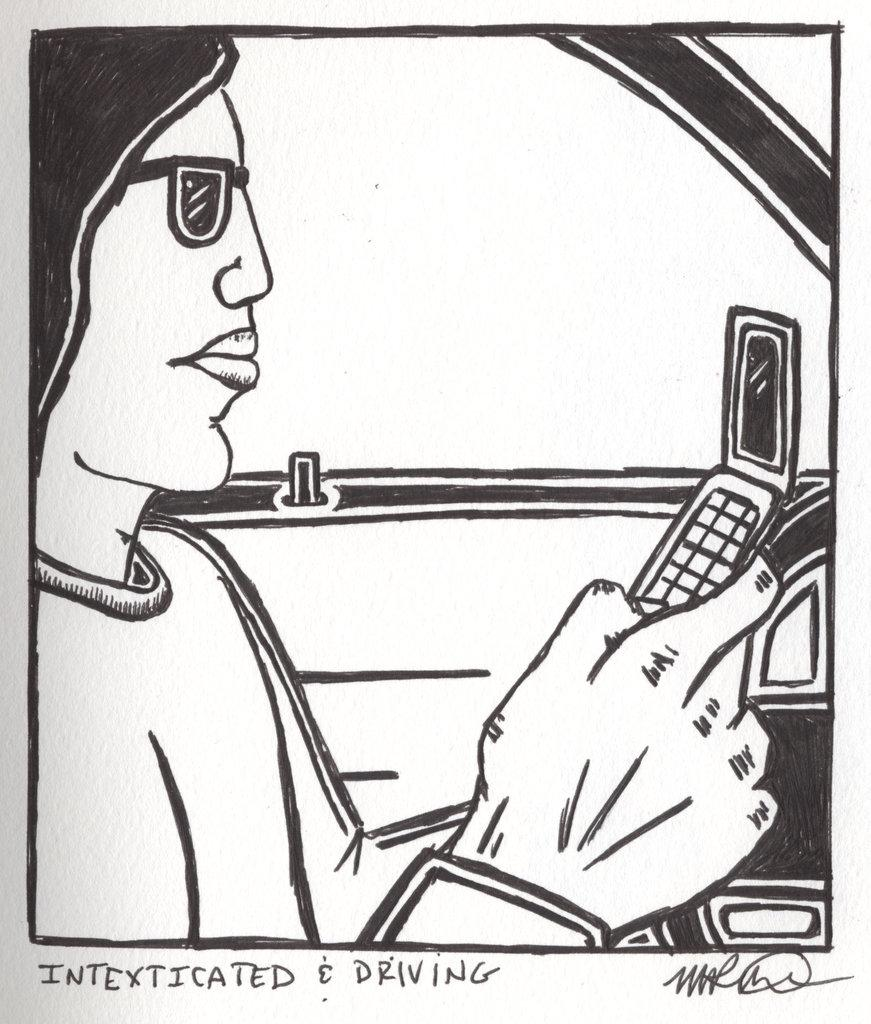What is depicted in the image? There is a drawing of a person in the image. What is the person in the drawing holding? The person in the drawing is holding a mobile. What can be found at the bottom of the image? There is text and a signature at the bottom of the image. How many men are visible in the image? There are no men visible in the image, as it only contains a drawing of a person. What type of power is being generated by the person in the drawing? The image does not depict any power generation; it is a drawing of a person holding a mobile. 